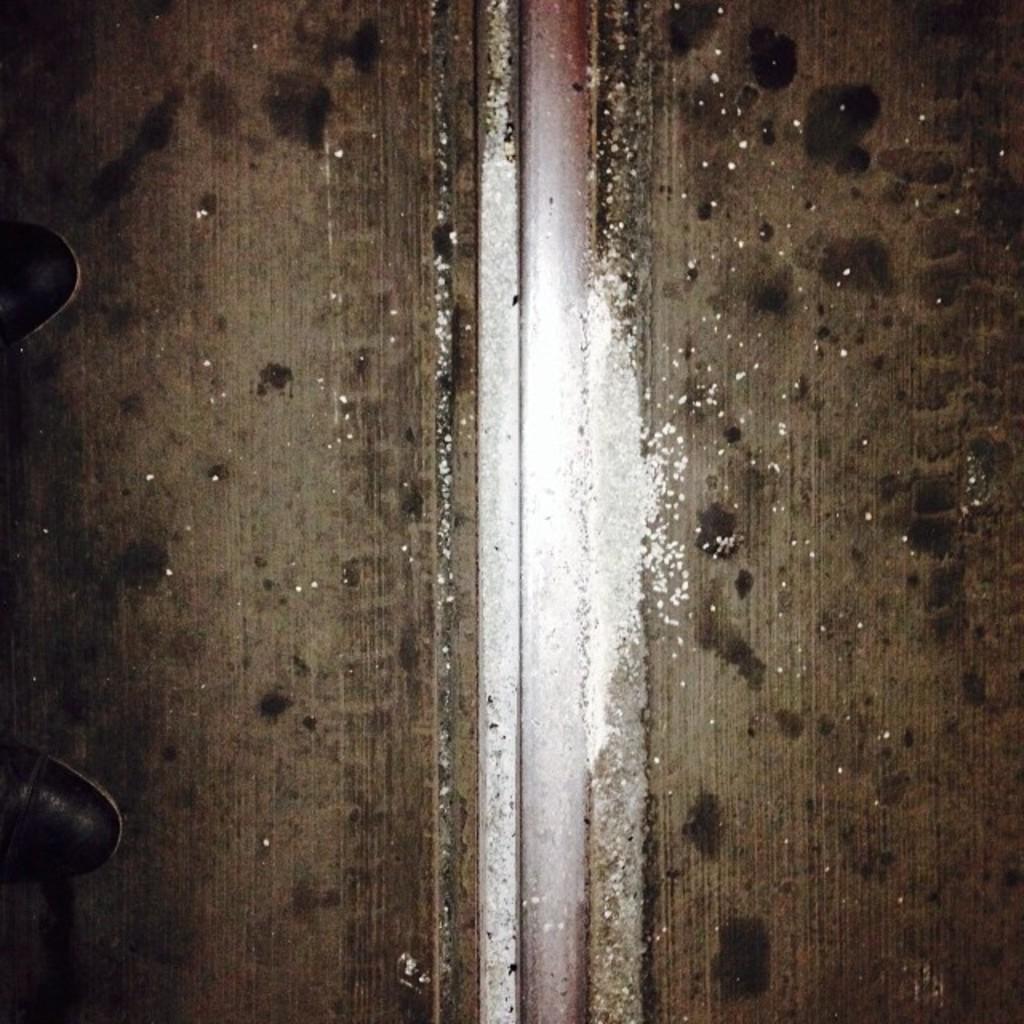Please provide a concise description of this image. In this picture there are two legs on the left side of the image and there is wooded way in the image. 